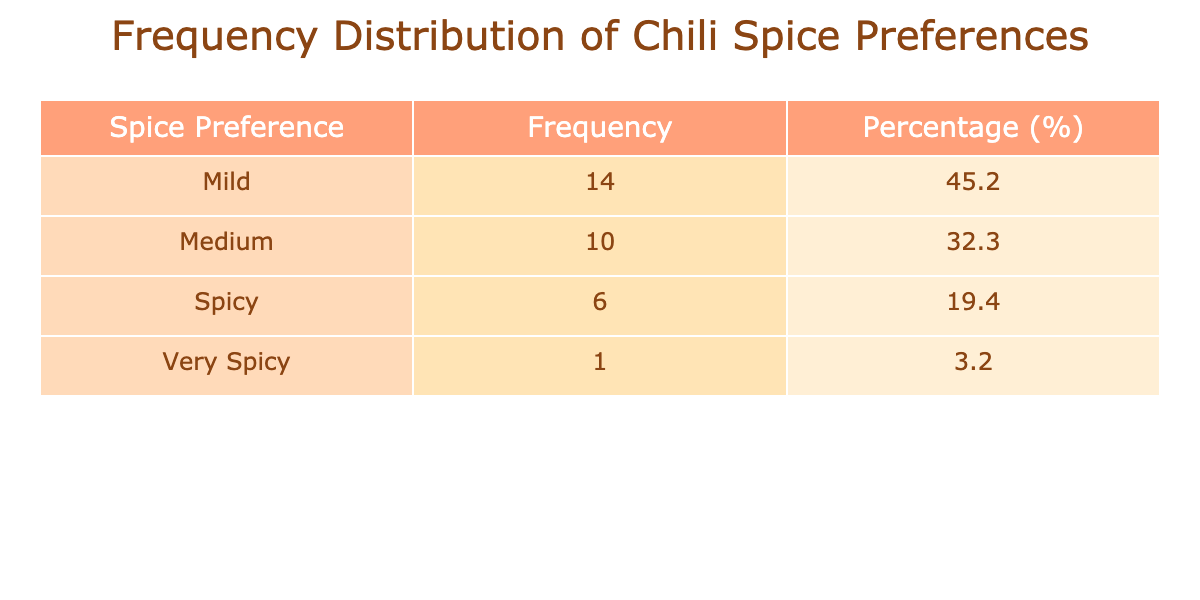What is the most popular spice preference among family members? The most popular spice preference can be found by looking at the "Frequency" column. In the table, "Medium" has the highest frequency of 10.
Answer: Medium How many family members prefer "Mild" spice? To find the number of family members who prefer "Mild", you can directly refer to the "Frequency" column for "Mild", which shows a total frequency of 10.
Answer: 10 Is there a spice preference that no family member chose? By checking the "Spice Preference" categories, there is no entry for "None" or any unselected option, indicating that all preferences listed were chosen by at least one family member.
Answer: No What is the total frequency of all spice preferences? The total frequency can be calculated by adding all the values in the "Frequency" column: 3 + 5 + 2 + 4 + 3 + 1 + 2 + 4 + 2 + 5 = 27.
Answer: 27 What percentage of family members prefer "Very Spicy"? The percentage for "Very Spicy" can be calculated using the frequency for "Very Spicy" (1) divided by the total frequency (27): (1/27) * 100 = 3.7%.
Answer: 3.7% What spice preference has the lowest frequency, and what is that frequency? The spice preference with the lowest frequency is "Very Spicy" with a frequency of 1, as evident from the table.
Answer: Very Spicy, 1 What is the difference in frequency between those who prefer "Medium" and "Spicy"? The frequency for "Medium" is 10 and for "Spicy" it is 6. The difference is calculated as 10 - 6 = 4.
Answer: 4 Which family member has the highest spice preference frequency, and what is that frequency? To find this, compare all frequencies. "Emily" and "Lisa" both have a frequency of 5, which is the highest among all members.
Answer: Emily and Lisa, 5 What is the average frequency of all spice preferences? To find the average frequency, sum all frequencies (27) and divide by the number of unique preferences (5): 27 / 5 = 5.4.
Answer: 5.4 